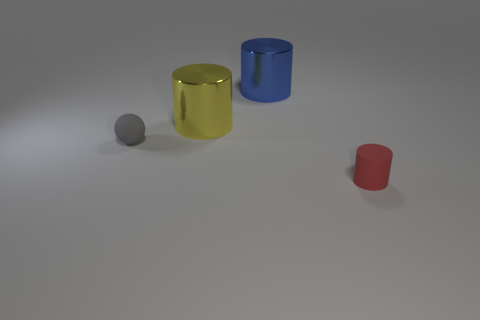Do the yellow thing and the tiny object on the right side of the tiny gray thing have the same shape?
Ensure brevity in your answer.  Yes. What color is the rubber object that is in front of the rubber object behind the cylinder in front of the tiny ball?
Offer a terse response. Red. There is a large yellow metallic object; are there any red rubber cylinders behind it?
Ensure brevity in your answer.  No. Are there any other blue objects that have the same material as the blue thing?
Offer a terse response. No. What is the color of the tiny ball?
Ensure brevity in your answer.  Gray. There is a matte thing to the right of the tiny matte sphere; does it have the same shape as the blue thing?
Keep it short and to the point. Yes. The tiny object right of the matte object that is left of the cylinder in front of the tiny gray ball is what shape?
Provide a succinct answer. Cylinder. What is the yellow cylinder that is behind the gray matte thing made of?
Give a very brief answer. Metal. What is the color of the matte thing that is the same size as the sphere?
Provide a succinct answer. Red. How many other things are the same shape as the gray object?
Your answer should be very brief. 0. 